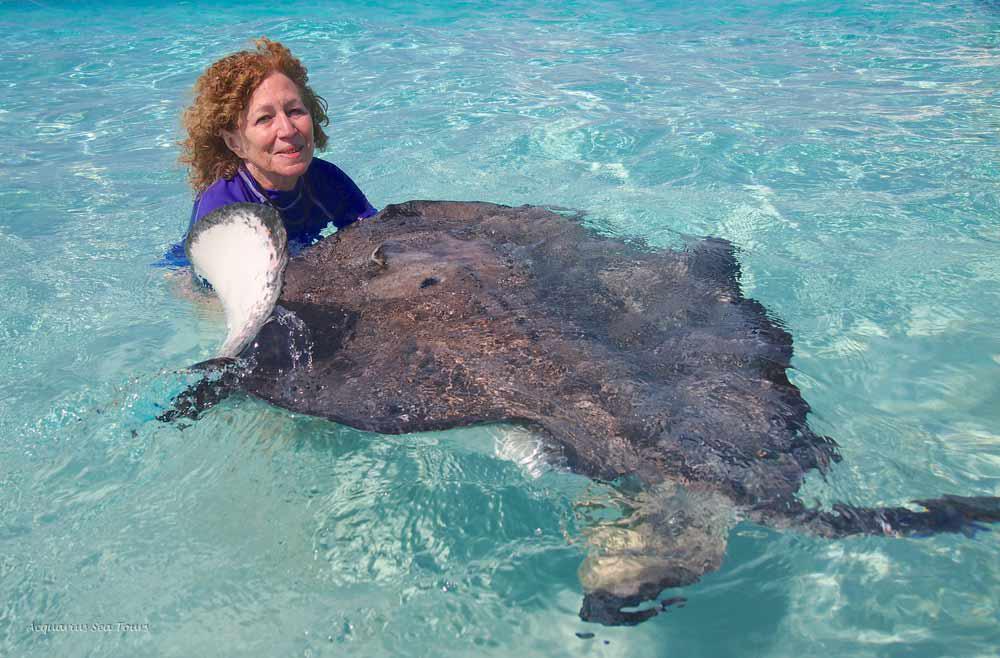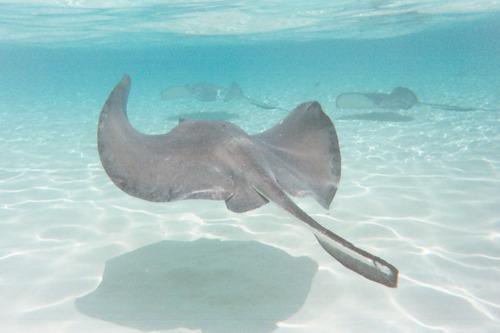The first image is the image on the left, the second image is the image on the right. Analyze the images presented: Is the assertion "A woman in a bikini is in the water next to a gray stingray." valid? Answer yes or no. No. The first image is the image on the left, the second image is the image on the right. For the images shown, is this caption "The woman in the left image is wearing a bikini; we can clearly see most of her bathing suit." true? Answer yes or no. No. 